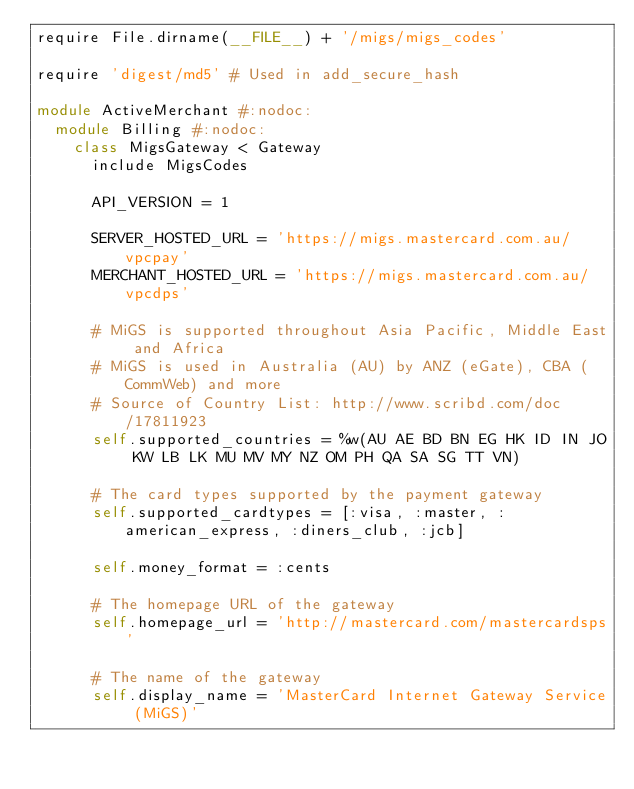<code> <loc_0><loc_0><loc_500><loc_500><_Ruby_>require File.dirname(__FILE__) + '/migs/migs_codes'

require 'digest/md5' # Used in add_secure_hash

module ActiveMerchant #:nodoc:
  module Billing #:nodoc:
    class MigsGateway < Gateway
      include MigsCodes

      API_VERSION = 1

      SERVER_HOSTED_URL = 'https://migs.mastercard.com.au/vpcpay'
      MERCHANT_HOSTED_URL = 'https://migs.mastercard.com.au/vpcdps'

      # MiGS is supported throughout Asia Pacific, Middle East and Africa
      # MiGS is used in Australia (AU) by ANZ (eGate), CBA (CommWeb) and more
      # Source of Country List: http://www.scribd.com/doc/17811923
      self.supported_countries = %w(AU AE BD BN EG HK ID IN JO KW LB LK MU MV MY NZ OM PH QA SA SG TT VN)

      # The card types supported by the payment gateway
      self.supported_cardtypes = [:visa, :master, :american_express, :diners_club, :jcb]

      self.money_format = :cents

      # The homepage URL of the gateway
      self.homepage_url = 'http://mastercard.com/mastercardsps'

      # The name of the gateway
      self.display_name = 'MasterCard Internet Gateway Service (MiGS)'
</code> 